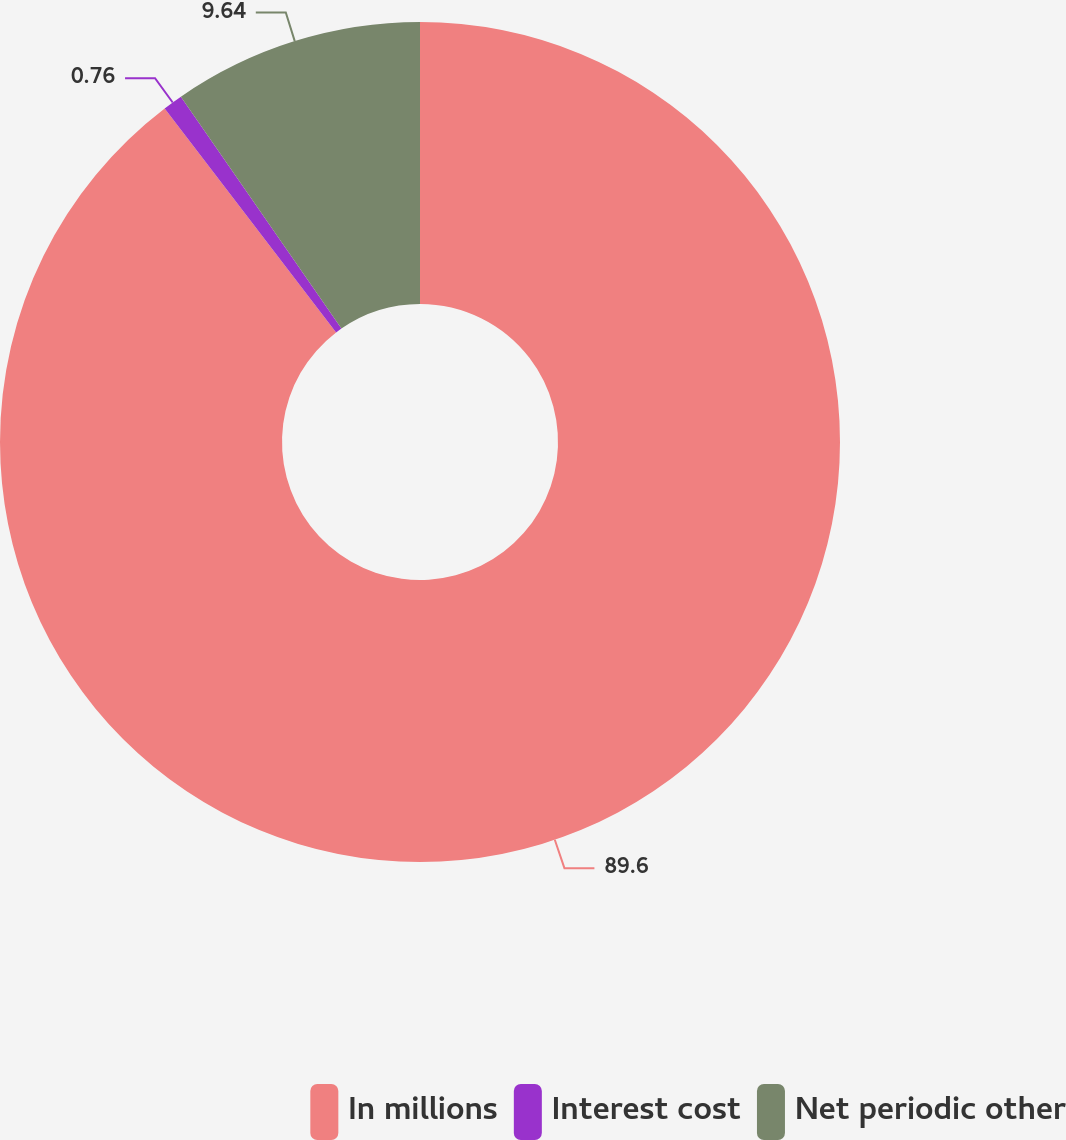<chart> <loc_0><loc_0><loc_500><loc_500><pie_chart><fcel>In millions<fcel>Interest cost<fcel>Net periodic other<nl><fcel>89.6%<fcel>0.76%<fcel>9.64%<nl></chart> 